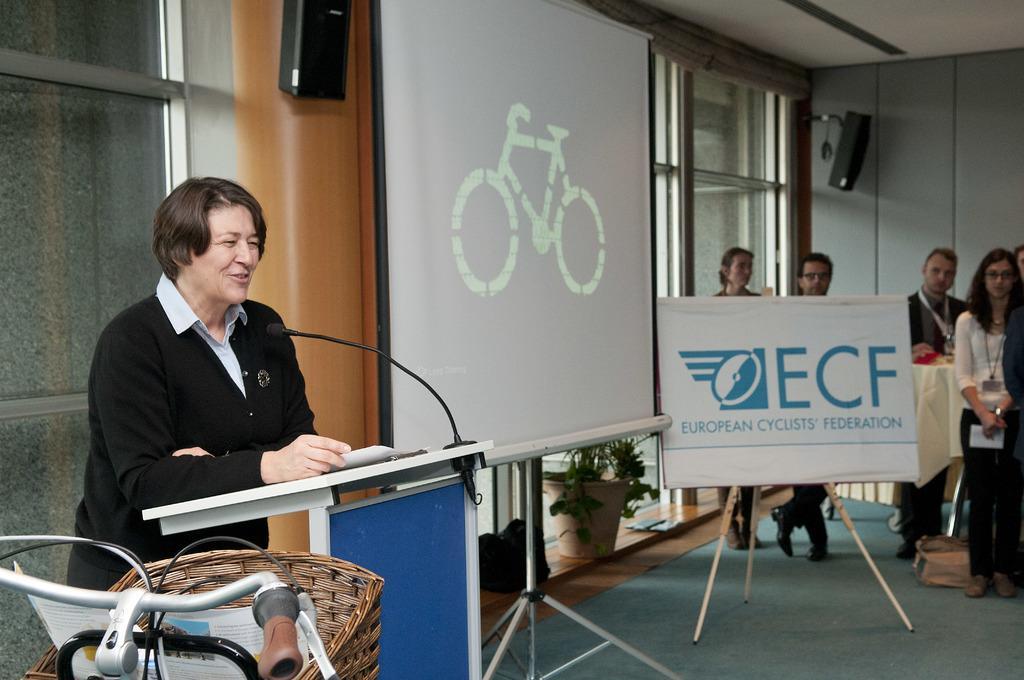Please provide a concise description of this image. In this image I can see the person standing in-front of the podium. On the podium I can see the paper and mic. To the left side of the person I can see the banner and the board. In the background I can see the group of people standing, window and the flower pot. To the left I can see the bicycle with brown color basket. 